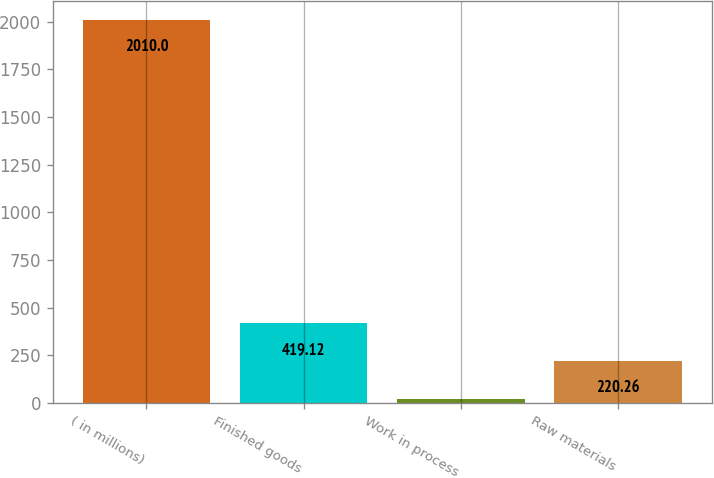Convert chart. <chart><loc_0><loc_0><loc_500><loc_500><bar_chart><fcel>( in millions)<fcel>Finished goods<fcel>Work in process<fcel>Raw materials<nl><fcel>2010<fcel>419.12<fcel>21.4<fcel>220.26<nl></chart> 